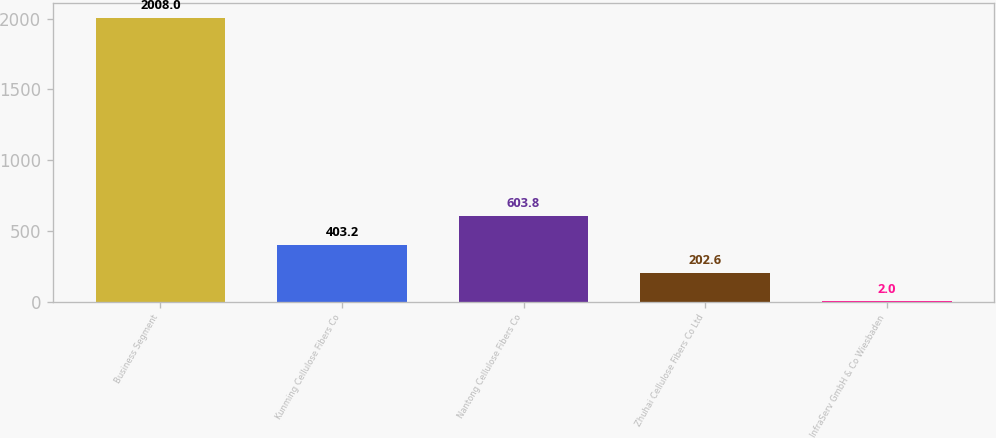<chart> <loc_0><loc_0><loc_500><loc_500><bar_chart><fcel>Business Segment<fcel>Kunming Cellulose Fibers Co<fcel>Nantong Cellulose Fibers Co<fcel>Zhuhai Cellulose Fibers Co Ltd<fcel>InfraServ GmbH & Co Wiesbaden<nl><fcel>2008<fcel>403.2<fcel>603.8<fcel>202.6<fcel>2<nl></chart> 